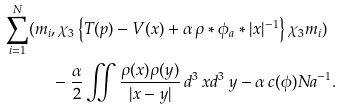Convert formula to latex. <formula><loc_0><loc_0><loc_500><loc_500>\sum _ { i = 1 } ^ { N } ( m _ { i } & , \chi _ { 3 } \left \{ T ( p ) - V ( x ) + \alpha \, \rho * \phi _ { a } * | x | ^ { - 1 } \right \} \chi _ { 3 } m _ { i } ) \\ & - \frac { \alpha } { 2 } \iint \frac { \rho ( x ) \rho ( y ) } { | x - y | } \, d ^ { 3 } \, x d ^ { 3 } \, y - \alpha \, c ( \phi ) N a ^ { - 1 } .</formula> 